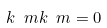<formula> <loc_0><loc_0><loc_500><loc_500>k ^ { \ } m k _ { \ } m = 0</formula> 